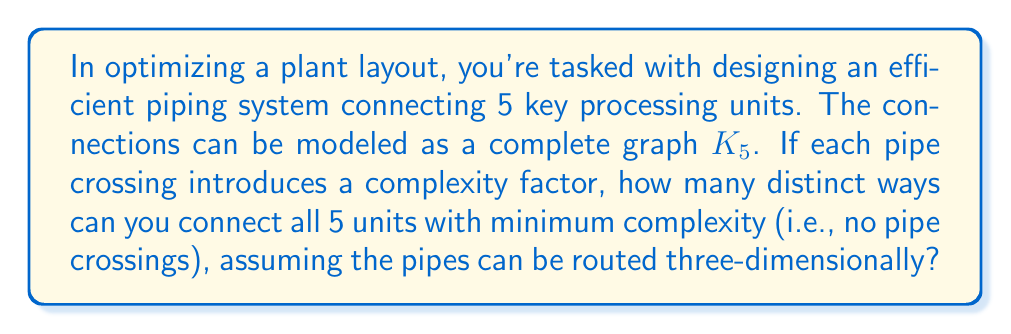Teach me how to tackle this problem. To solve this problem, we'll use concepts from both knot theory and graph theory:

1) In graph theory, a complete graph with 5 vertices ($K_5$) is not planar, meaning it cannot be drawn on a plane without edge crossings.

2) However, in 3D space, we can avoid crossings. This relates to knot theory, where we consider embeddings of graphs in 3D space.

3) The number of ways to connect the units without crossings is equivalent to the number of distinct spatial embeddings of $K_5$.

4) In knot theory, this is known as the number of "spatial graphs" for $K_5$.

5) According to research in spatial graph theory:
   
   $$\text{Number of spatial }K_5 = 3$$

6) These three distinct spatial embeddings of $K_5$ are:
   - The standard embedding
   - The "trefoil" embedding
   - The "figure-eight" embedding

Each of these represents a way to connect all 5 units with no pipe crossings in 3D space.
Answer: 3 